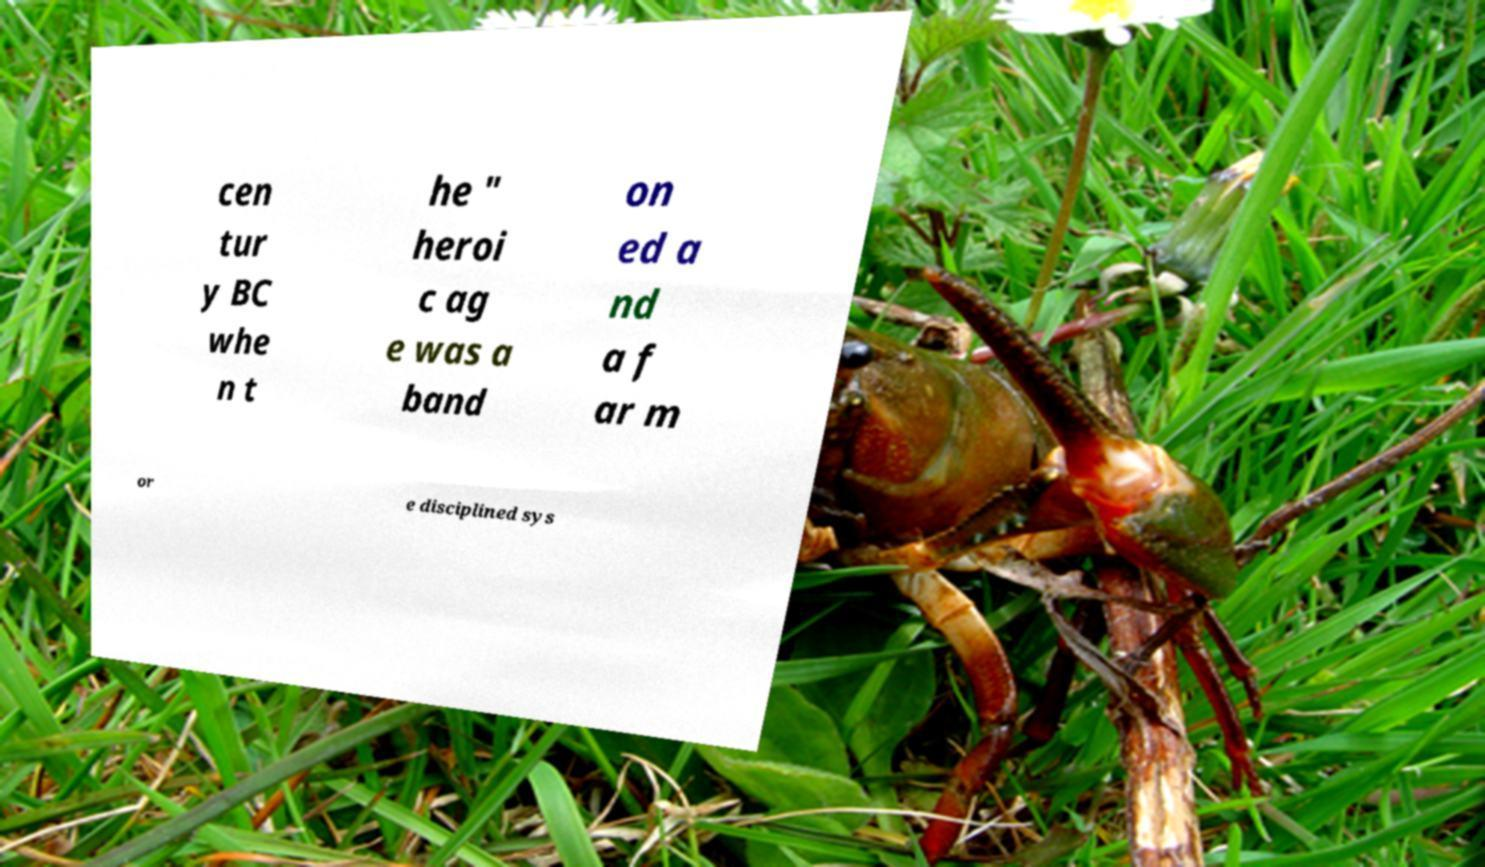For documentation purposes, I need the text within this image transcribed. Could you provide that? cen tur y BC whe n t he " heroi c ag e was a band on ed a nd a f ar m or e disciplined sys 